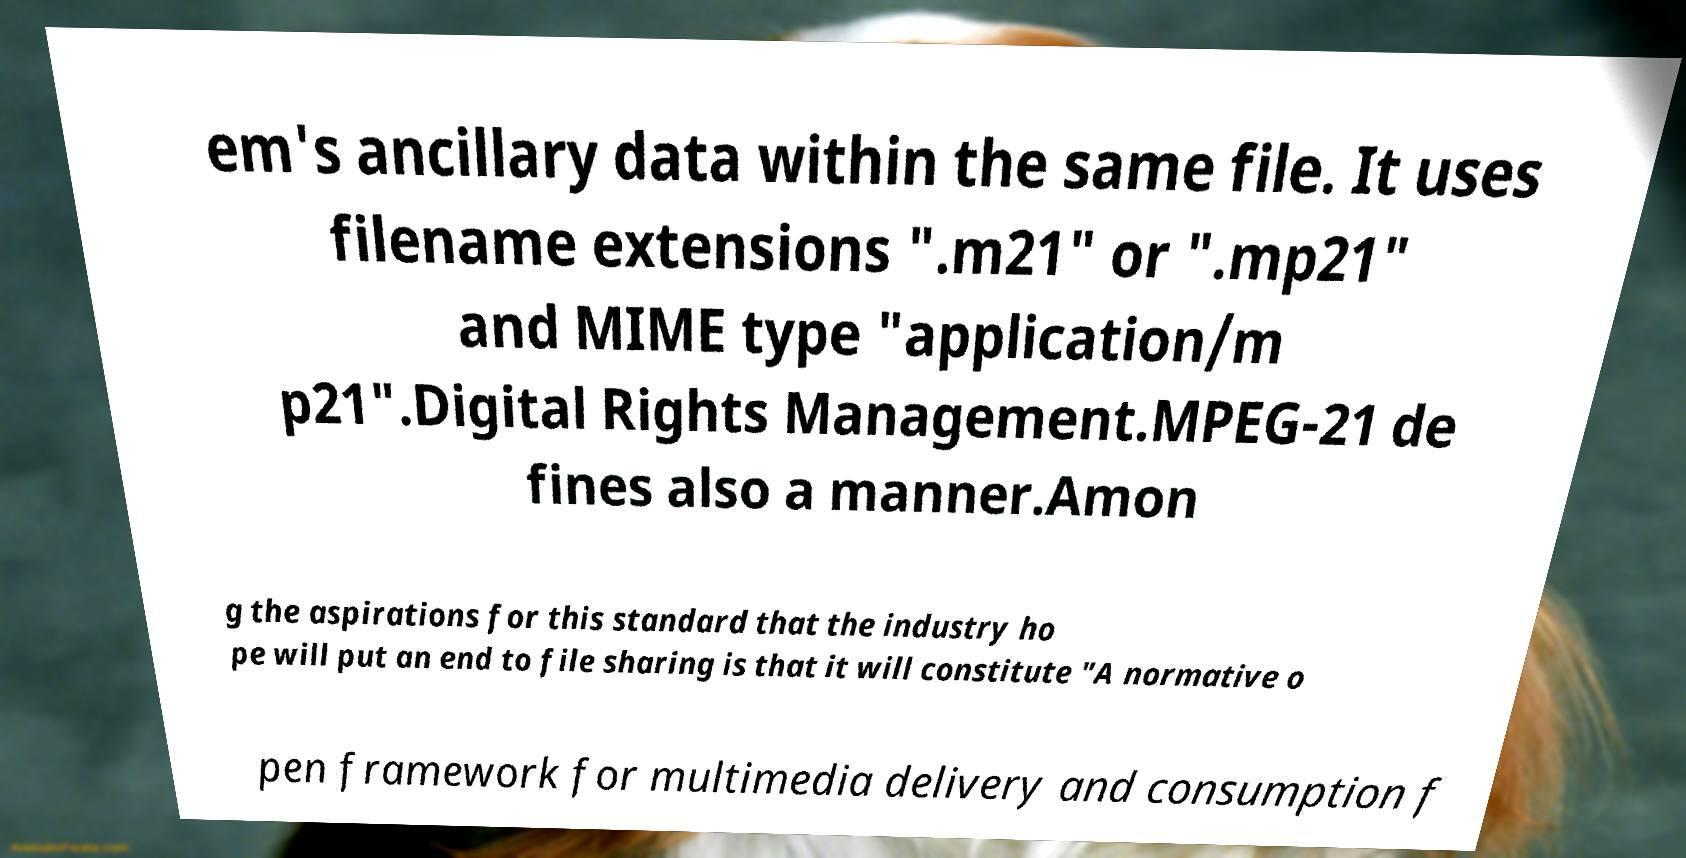Please identify and transcribe the text found in this image. em's ancillary data within the same file. It uses filename extensions ".m21" or ".mp21" and MIME type "application/m p21".Digital Rights Management.MPEG-21 de fines also a manner.Amon g the aspirations for this standard that the industry ho pe will put an end to file sharing is that it will constitute "A normative o pen framework for multimedia delivery and consumption f 